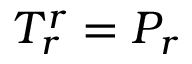Convert formula to latex. <formula><loc_0><loc_0><loc_500><loc_500>T _ { r } ^ { r } = P _ { r }</formula> 